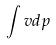<formula> <loc_0><loc_0><loc_500><loc_500>\int v d p</formula> 